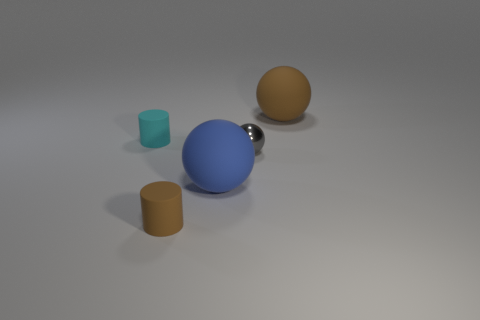Add 4 big brown spheres. How many objects exist? 9 Add 2 cyan cylinders. How many cyan cylinders are left? 3 Add 4 tiny shiny cylinders. How many tiny shiny cylinders exist? 4 Subtract 0 purple cylinders. How many objects are left? 5 Subtract all cylinders. How many objects are left? 3 Subtract all small gray metal objects. Subtract all gray shiny objects. How many objects are left? 3 